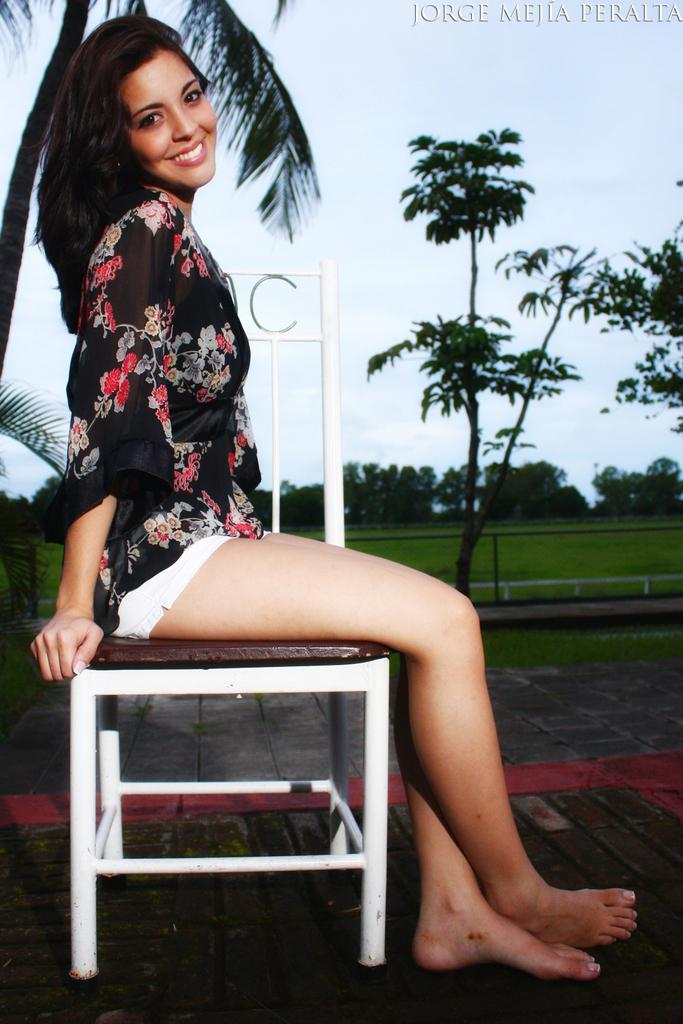Who is present in the image? There is a woman in the image. What is the woman doing in the image? The woman is sitting on a chair. What is the woman's facial expression in the image? The woman is smiling. What can be seen in the background of the image? There are trees in the background of the image. What type of natural environment is visible in the image? Grass is visible in the image. What part of the natural environment is visible in the image? The sky is visible in the image. What verse is the woman reciting in the image? There is no indication in the image that the woman is reciting a verse. How many toes can be seen on the woman's feet in the image? The image does not show the woman's feet, so the number of toes cannot be determined. 